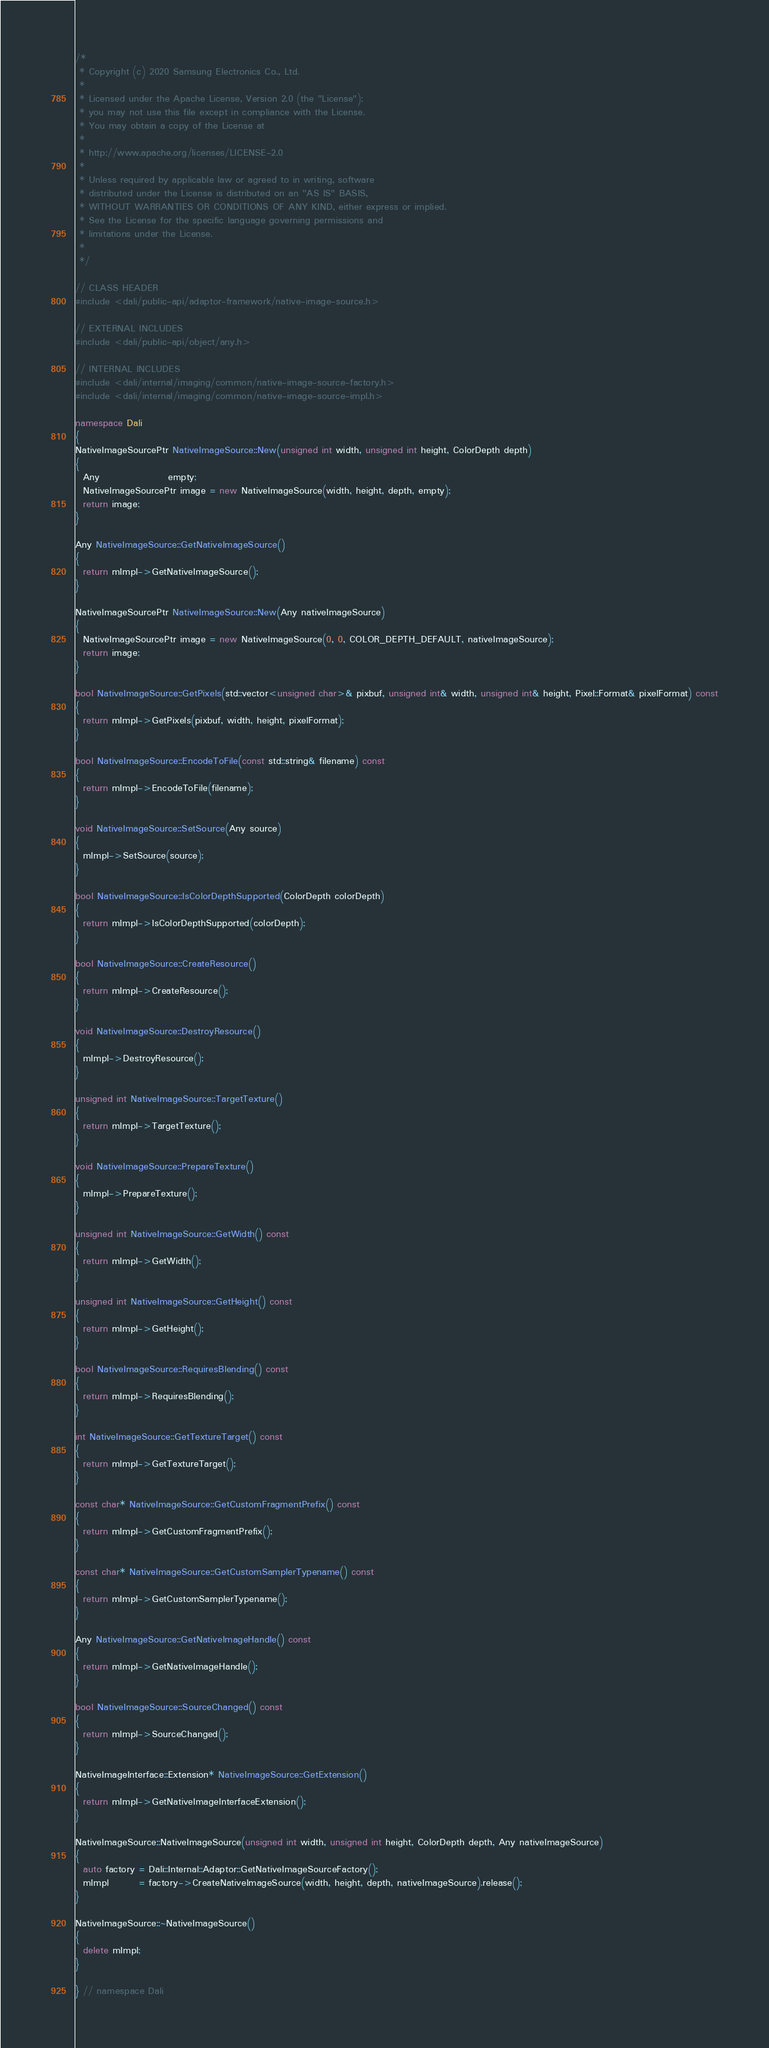<code> <loc_0><loc_0><loc_500><loc_500><_C++_>/*
 * Copyright (c) 2020 Samsung Electronics Co., Ltd.
 *
 * Licensed under the Apache License, Version 2.0 (the "License");
 * you may not use this file except in compliance with the License.
 * You may obtain a copy of the License at
 *
 * http://www.apache.org/licenses/LICENSE-2.0
 *
 * Unless required by applicable law or agreed to in writing, software
 * distributed under the License is distributed on an "AS IS" BASIS,
 * WITHOUT WARRANTIES OR CONDITIONS OF ANY KIND, either express or implied.
 * See the License for the specific language governing permissions and
 * limitations under the License.
 *
 */

// CLASS HEADER
#include <dali/public-api/adaptor-framework/native-image-source.h>

// EXTERNAL INCLUDES
#include <dali/public-api/object/any.h>

// INTERNAL INCLUDES
#include <dali/internal/imaging/common/native-image-source-factory.h>
#include <dali/internal/imaging/common/native-image-source-impl.h>

namespace Dali
{
NativeImageSourcePtr NativeImageSource::New(unsigned int width, unsigned int height, ColorDepth depth)
{
  Any                  empty;
  NativeImageSourcePtr image = new NativeImageSource(width, height, depth, empty);
  return image;
}

Any NativeImageSource::GetNativeImageSource()
{
  return mImpl->GetNativeImageSource();
}

NativeImageSourcePtr NativeImageSource::New(Any nativeImageSource)
{
  NativeImageSourcePtr image = new NativeImageSource(0, 0, COLOR_DEPTH_DEFAULT, nativeImageSource);
  return image;
}

bool NativeImageSource::GetPixels(std::vector<unsigned char>& pixbuf, unsigned int& width, unsigned int& height, Pixel::Format& pixelFormat) const
{
  return mImpl->GetPixels(pixbuf, width, height, pixelFormat);
}

bool NativeImageSource::EncodeToFile(const std::string& filename) const
{
  return mImpl->EncodeToFile(filename);
}

void NativeImageSource::SetSource(Any source)
{
  mImpl->SetSource(source);
}

bool NativeImageSource::IsColorDepthSupported(ColorDepth colorDepth)
{
  return mImpl->IsColorDepthSupported(colorDepth);
}

bool NativeImageSource::CreateResource()
{
  return mImpl->CreateResource();
}

void NativeImageSource::DestroyResource()
{
  mImpl->DestroyResource();
}

unsigned int NativeImageSource::TargetTexture()
{
  return mImpl->TargetTexture();
}

void NativeImageSource::PrepareTexture()
{
  mImpl->PrepareTexture();
}

unsigned int NativeImageSource::GetWidth() const
{
  return mImpl->GetWidth();
}

unsigned int NativeImageSource::GetHeight() const
{
  return mImpl->GetHeight();
}

bool NativeImageSource::RequiresBlending() const
{
  return mImpl->RequiresBlending();
}

int NativeImageSource::GetTextureTarget() const
{
  return mImpl->GetTextureTarget();
}

const char* NativeImageSource::GetCustomFragmentPrefix() const
{
  return mImpl->GetCustomFragmentPrefix();
}

const char* NativeImageSource::GetCustomSamplerTypename() const
{
  return mImpl->GetCustomSamplerTypename();
}

Any NativeImageSource::GetNativeImageHandle() const
{
  return mImpl->GetNativeImageHandle();
}

bool NativeImageSource::SourceChanged() const
{
  return mImpl->SourceChanged();
}

NativeImageInterface::Extension* NativeImageSource::GetExtension()
{
  return mImpl->GetNativeImageInterfaceExtension();
}

NativeImageSource::NativeImageSource(unsigned int width, unsigned int height, ColorDepth depth, Any nativeImageSource)
{
  auto factory = Dali::Internal::Adaptor::GetNativeImageSourceFactory();
  mImpl        = factory->CreateNativeImageSource(width, height, depth, nativeImageSource).release();
}

NativeImageSource::~NativeImageSource()
{
  delete mImpl;
}

} // namespace Dali
</code> 